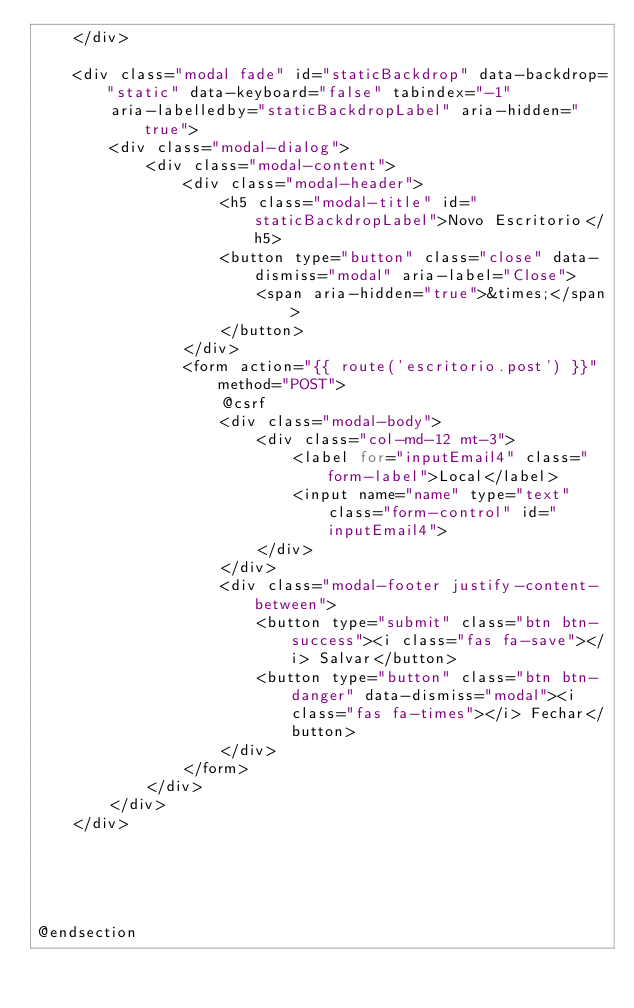<code> <loc_0><loc_0><loc_500><loc_500><_PHP_>    </div>

    <div class="modal fade" id="staticBackdrop" data-backdrop="static" data-keyboard="false" tabindex="-1"
        aria-labelledby="staticBackdropLabel" aria-hidden="true">
        <div class="modal-dialog">
            <div class="modal-content">
                <div class="modal-header">
                    <h5 class="modal-title" id="staticBackdropLabel">Novo Escritorio</h5>
                    <button type="button" class="close" data-dismiss="modal" aria-label="Close">
                        <span aria-hidden="true">&times;</span>
                    </button>
                </div>
                <form action="{{ route('escritorio.post') }}" method="POST">
                    @csrf
                    <div class="modal-body">
                        <div class="col-md-12 mt-3">
                            <label for="inputEmail4" class="form-label">Local</label>
                            <input name="name" type="text" class="form-control" id="inputEmail4">
                        </div>
                    </div>
                    <div class="modal-footer justify-content-between">
                        <button type="submit" class="btn btn-success"><i class="fas fa-save"></i> Salvar</button>
                        <button type="button" class="btn btn-danger" data-dismiss="modal"><i class="fas fa-times"></i> Fechar</button>
                    </div>
                </form>
            </div>
        </div>
    </div>





@endsection
</code> 